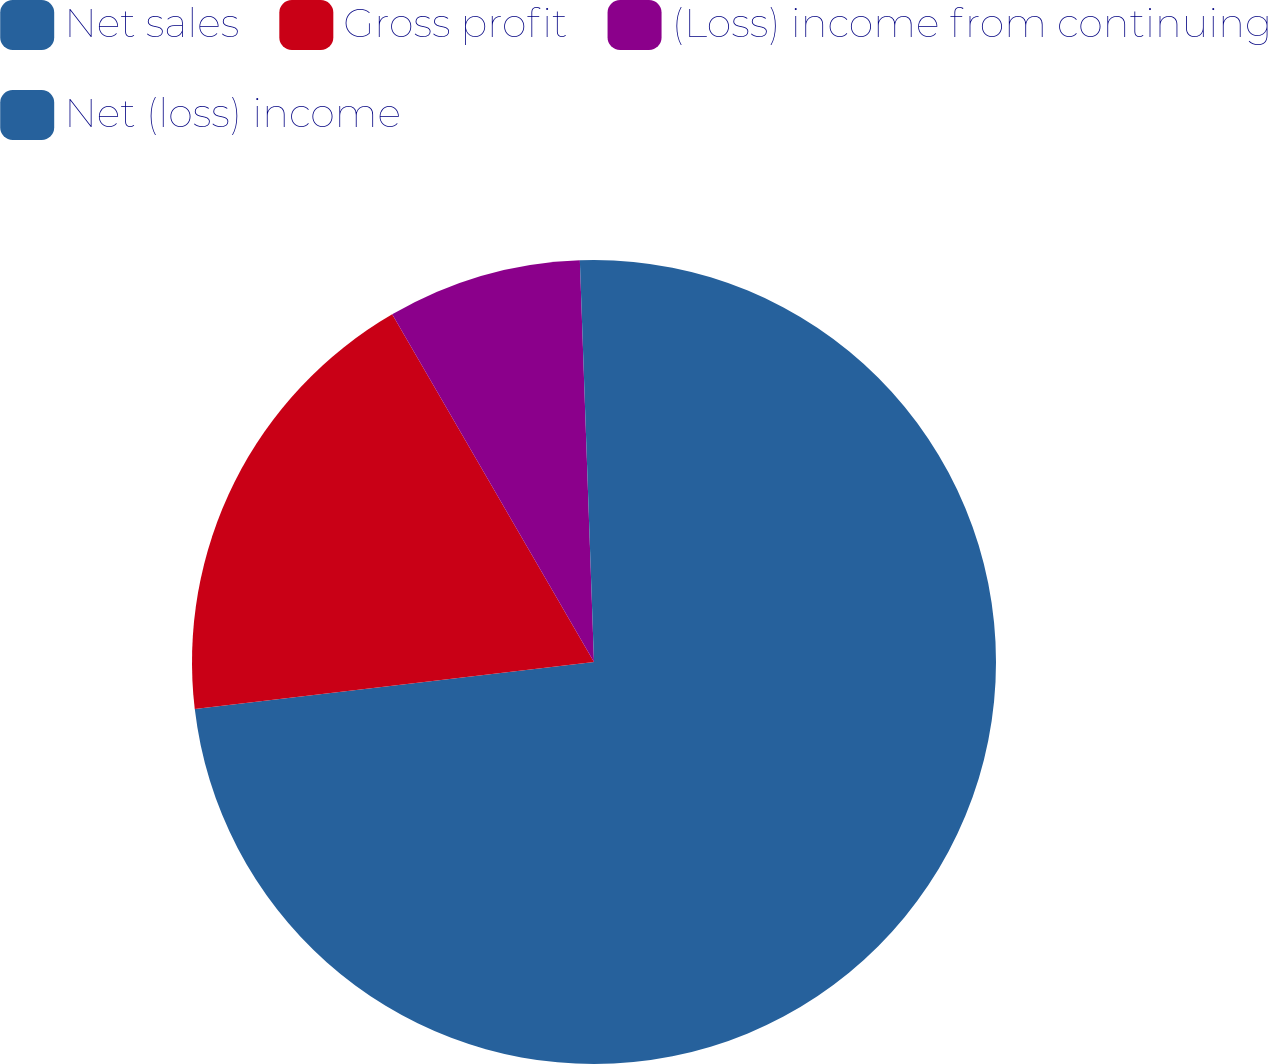Convert chart to OTSL. <chart><loc_0><loc_0><loc_500><loc_500><pie_chart><fcel>Net sales<fcel>Gross profit<fcel>(Loss) income from continuing<fcel>Net (loss) income<nl><fcel>73.13%<fcel>18.5%<fcel>7.81%<fcel>0.56%<nl></chart> 